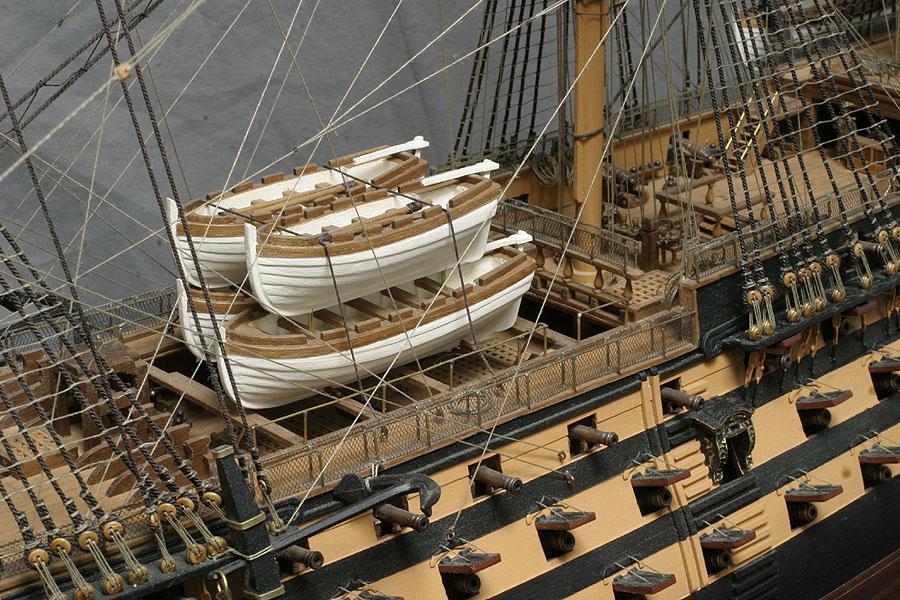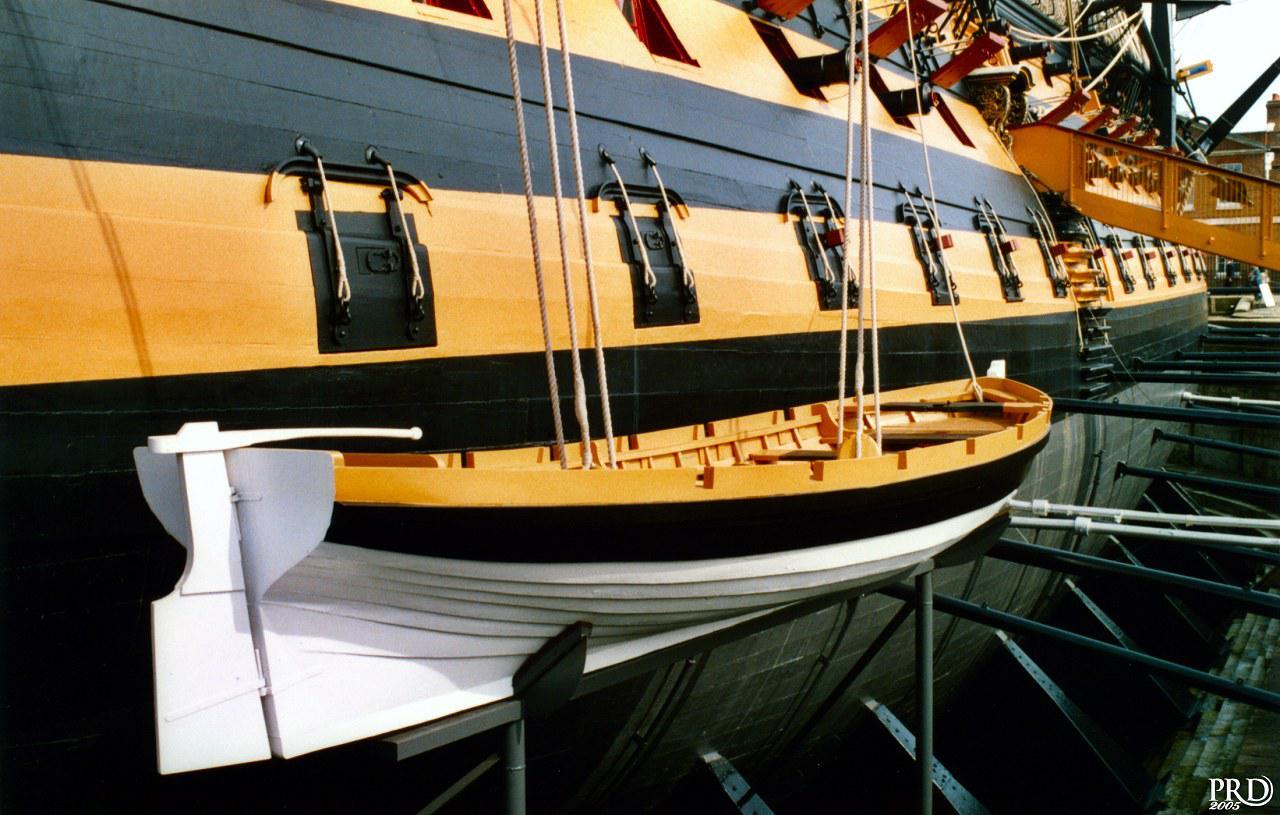The first image is the image on the left, the second image is the image on the right. Examine the images to the left and right. Is the description "An image shows one white-bottomed boat on the exterior side of a ship, below a line of square ports." accurate? Answer yes or no. Yes. The first image is the image on the left, the second image is the image on the right. Considering the images on both sides, is "At least one image shows re-enactors, people wearing period clothing, on or near a boat." valid? Answer yes or no. No. 